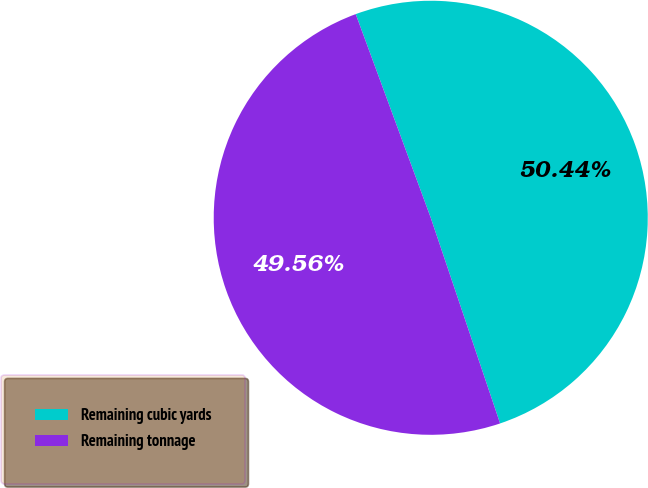<chart> <loc_0><loc_0><loc_500><loc_500><pie_chart><fcel>Remaining cubic yards<fcel>Remaining tonnage<nl><fcel>50.44%<fcel>49.56%<nl></chart> 